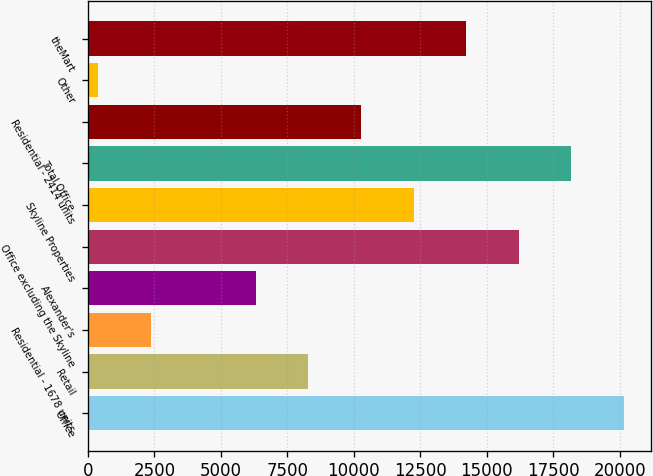Convert chart to OTSL. <chart><loc_0><loc_0><loc_500><loc_500><bar_chart><fcel>Office<fcel>Retail<fcel>Residential - 1678 units<fcel>Alexander's<fcel>Office excluding the Skyline<fcel>Skyline Properties<fcel>Total Office<fcel>Residential - 2414 units<fcel>Other<fcel>theMart<nl><fcel>20154<fcel>8292<fcel>2361<fcel>6315<fcel>16200<fcel>12246<fcel>18177<fcel>10269<fcel>384<fcel>14223<nl></chart> 